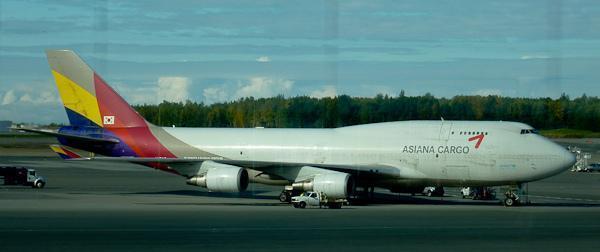How many car doors are open?
Give a very brief answer. 0. 